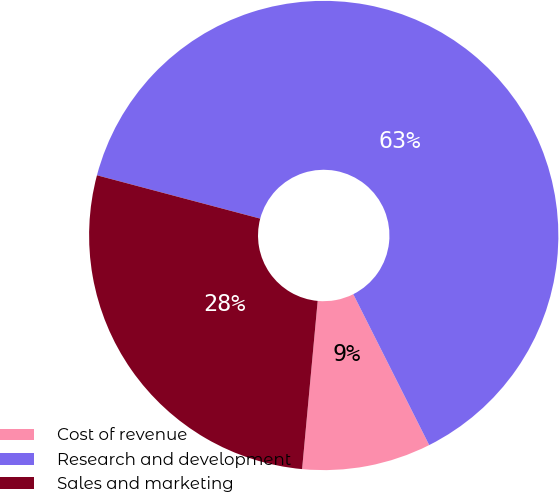Convert chart. <chart><loc_0><loc_0><loc_500><loc_500><pie_chart><fcel>Cost of revenue<fcel>Research and development<fcel>Sales and marketing<nl><fcel>8.89%<fcel>63.45%<fcel>27.66%<nl></chart> 